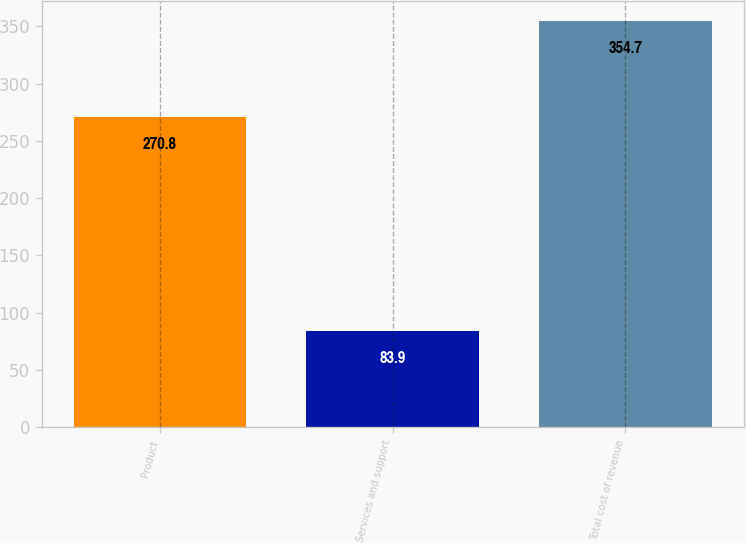<chart> <loc_0><loc_0><loc_500><loc_500><bar_chart><fcel>Product<fcel>Services and support<fcel>Total cost of revenue<nl><fcel>270.8<fcel>83.9<fcel>354.7<nl></chart> 